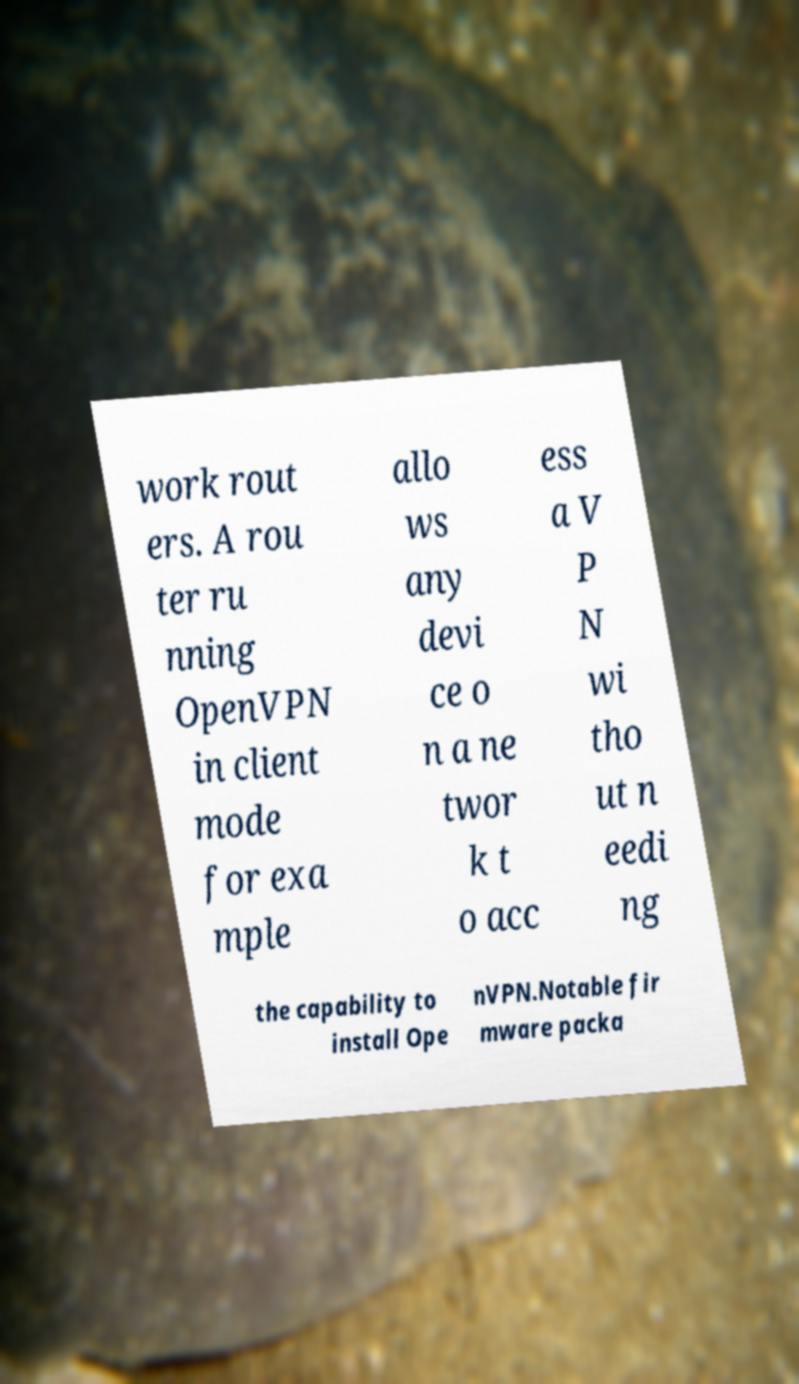Please read and relay the text visible in this image. What does it say? work rout ers. A rou ter ru nning OpenVPN in client mode for exa mple allo ws any devi ce o n a ne twor k t o acc ess a V P N wi tho ut n eedi ng the capability to install Ope nVPN.Notable fir mware packa 